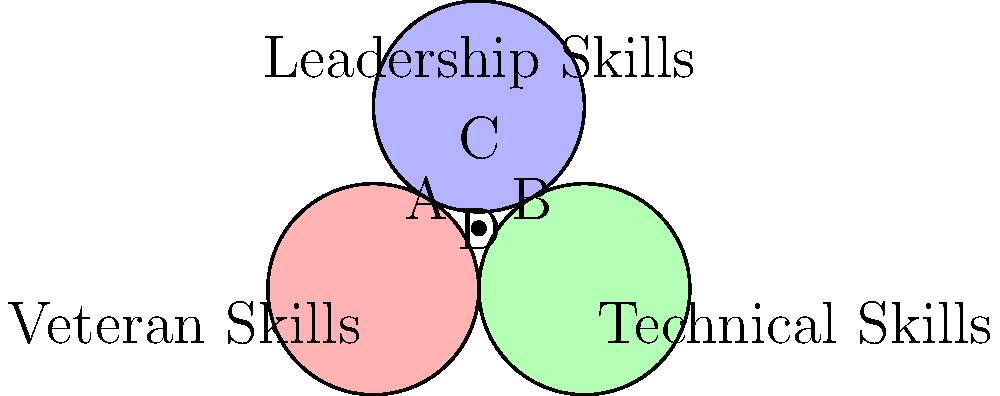Based on the Venn diagram illustrating the overlap between veteran skills, technical skills, and leadership skills, which area represents candidates who possess all three skill sets? What percentage of the total area does this region approximately cover? To answer this question, we need to analyze the Venn diagram and identify the area where all three circles intersect. Let's break it down step-by-step:

1. Identify the overlapping region:
   The area where all three circles intersect is labeled "D" in the center of the diagram.

2. Understand what each circle represents:
   - Red circle: Veteran Skills
   - Green circle: Technical Skills
   - Blue circle: Leadership Skills

3. Interpret the overlap:
   Area D represents candidates who possess all three skill sets: veteran skills, technical skills, and leadership skills.

4. Estimate the percentage:
   To estimate the percentage, we need to visually compare the size of area D to the total area of all circles combined.

   - Area D is relatively small compared to the entire diagram.
   - It appears to cover approximately 5-10% of the total area.

5. Consider the implications:
   This small overlap suggests that candidates possessing all three skill sets are relatively rare and potentially valuable for inclusive workplaces.

Given the visual estimation, we can conclude that area D represents approximately 7% of the total area. This percentage is an estimate based on visual inspection and may vary slightly depending on individual interpretation.
Answer: Area D; approximately 7% 